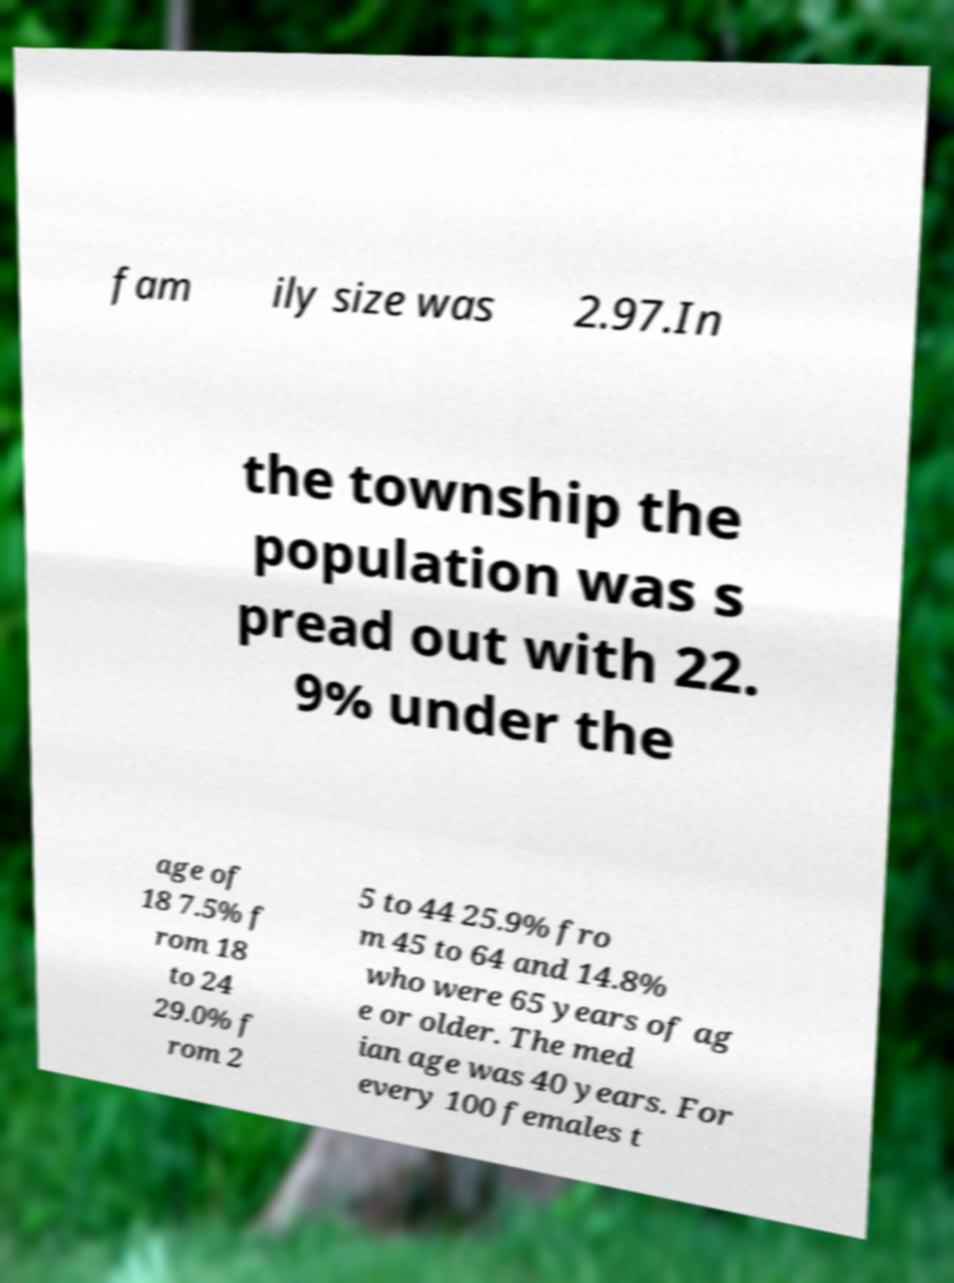Could you assist in decoding the text presented in this image and type it out clearly? fam ily size was 2.97.In the township the population was s pread out with 22. 9% under the age of 18 7.5% f rom 18 to 24 29.0% f rom 2 5 to 44 25.9% fro m 45 to 64 and 14.8% who were 65 years of ag e or older. The med ian age was 40 years. For every 100 females t 